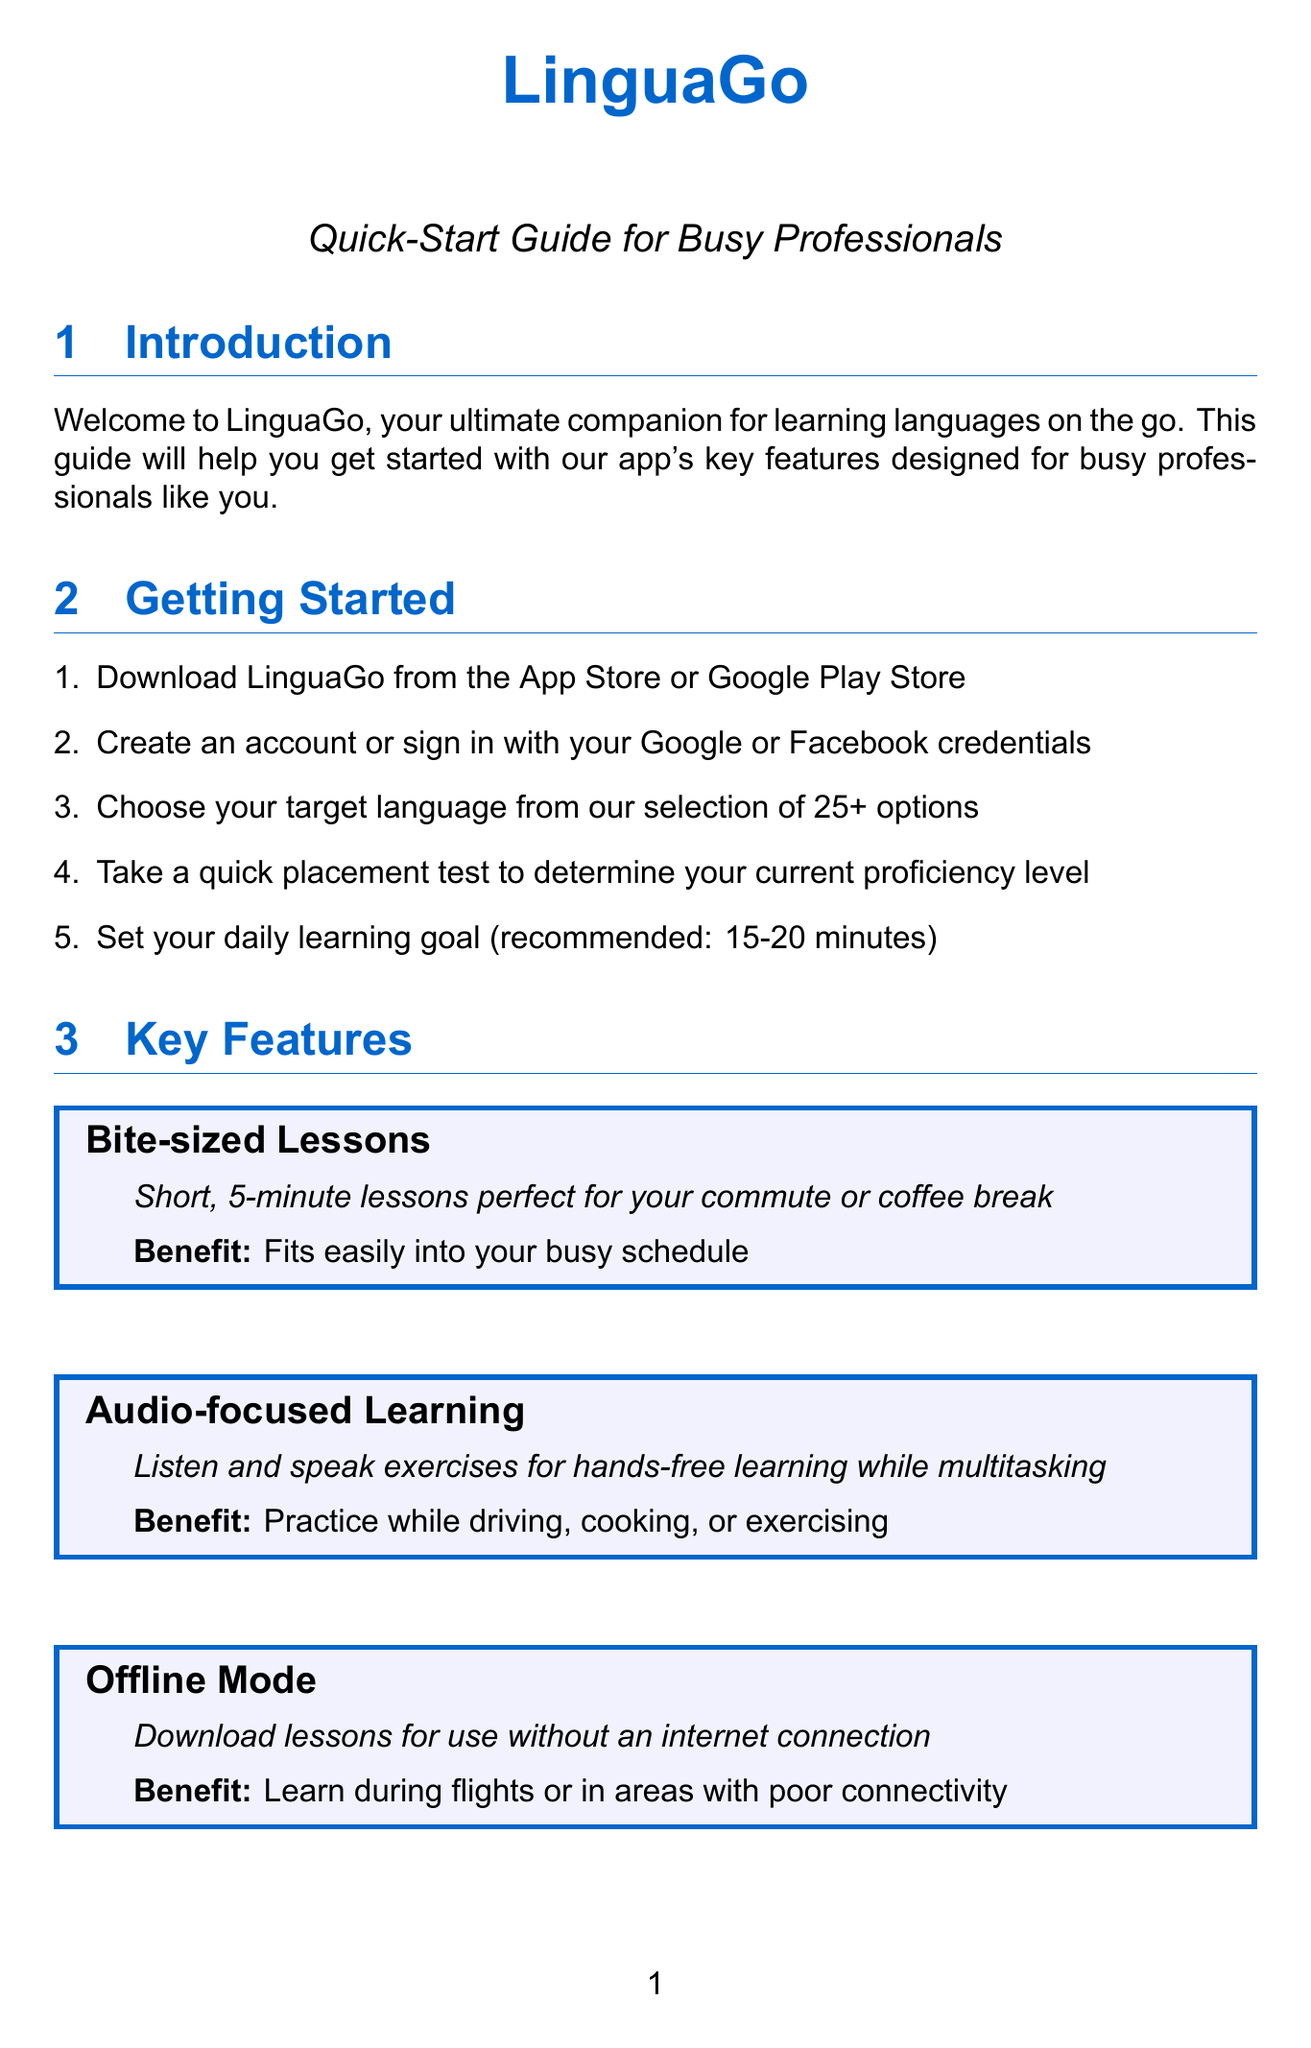what is the name of the app? The document mentions that the app's name is LinguaGo.
Answer: LinguaGo how many language options does the app offer? The quick-start guide states that the app offers 25+ language options.
Answer: 25+ what is the recommended daily learning goal? The document recommends setting a daily learning goal of 15-20 minutes.
Answer: 15-20 minutes what feature is designed for hands-free learning? The guide describes the Audio-focused Learning feature for hands-free learning exercises.
Answer: Audio-focused Learning what should you do if the app crashes during a lesson? The troubleshooting section suggests ensuring the app is updated to the latest version.
Answer: Update the app what can you use the Quick Practice feature for? It is for a 2-minute vocabulary review when you have a moment to spare.
Answer: Vocabulary review when is customer support available? The document states that customer support is available Monday to Friday from 9 AM to 6 PM EST.
Answer: 9 AM - 6 PM EST what does the Personalized Review feature help optimize? The Personalized Review feature helps optimize your learning to save time.
Answer: Learning efficiency what should you do if you can't connect to servers? It suggests verifying your internet connection or trying offline mode.
Answer: Verify internet connection or use offline mode 